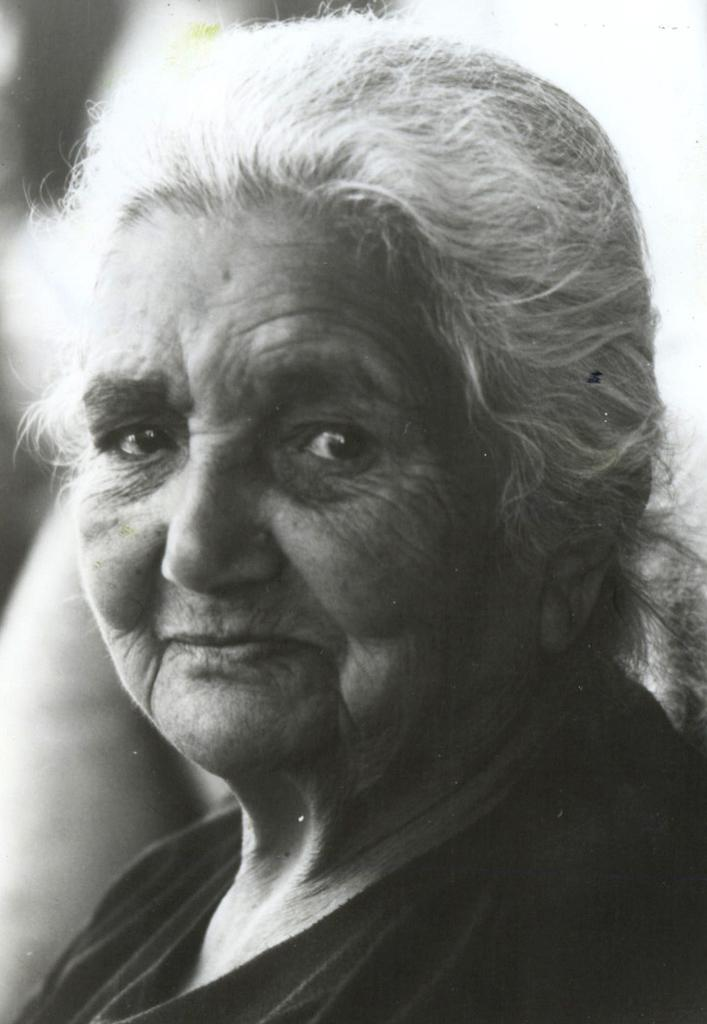Who is the main subject in the image? There is a woman in the image. What can be observed about the woman's hair? The woman's hair is white. What type of clothing is the woman wearing? The woman is wearing a black t-shirt. What type of pin is the woman wearing on her shirt in the image? There is no pin visible on the woman's shirt in the image. What authority does the woman have in the image? The image does not provide any information about the woman's authority or position. Is there a plane visible in the image? There is no plane present in the image. 